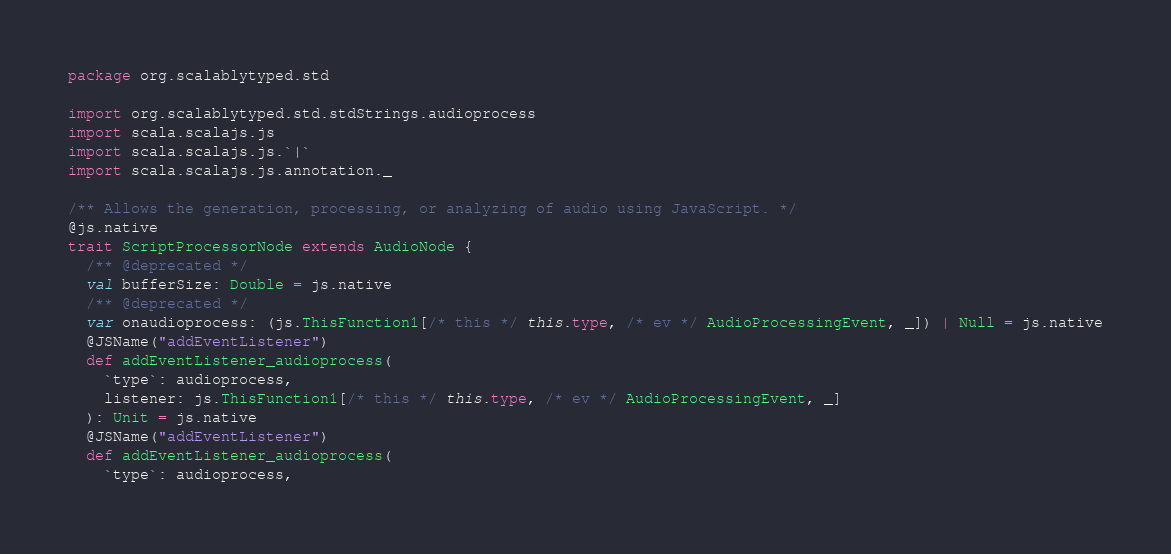<code> <loc_0><loc_0><loc_500><loc_500><_Scala_>package org.scalablytyped.std

import org.scalablytyped.std.stdStrings.audioprocess
import scala.scalajs.js
import scala.scalajs.js.`|`
import scala.scalajs.js.annotation._

/** Allows the generation, processing, or analyzing of audio using JavaScript. */
@js.native
trait ScriptProcessorNode extends AudioNode {
  /** @deprecated */
  val bufferSize: Double = js.native
  /** @deprecated */
  var onaudioprocess: (js.ThisFunction1[/* this */ this.type, /* ev */ AudioProcessingEvent, _]) | Null = js.native
  @JSName("addEventListener")
  def addEventListener_audioprocess(
    `type`: audioprocess,
    listener: js.ThisFunction1[/* this */ this.type, /* ev */ AudioProcessingEvent, _]
  ): Unit = js.native
  @JSName("addEventListener")
  def addEventListener_audioprocess(
    `type`: audioprocess,</code> 